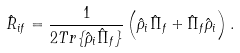Convert formula to latex. <formula><loc_0><loc_0><loc_500><loc_500>\hat { R } _ { i f } = \frac { 1 } { 2 T r \{ \hat { \rho } _ { i } \hat { \Pi } _ { f } \} } \left ( \hat { \rho } _ { i } \hat { \Pi } _ { f } + \hat { \Pi } _ { f } \hat { \rho } _ { i } \right ) .</formula> 